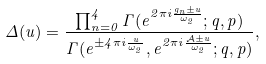<formula> <loc_0><loc_0><loc_500><loc_500>\Delta ( u ) = \frac { \prod _ { n = 0 } ^ { 4 } \Gamma ( e ^ { 2 \pi i \frac { g _ { n } \pm u } { \omega _ { 2 } } } ; q , p ) } { \Gamma ( e ^ { \pm 4 \pi i \frac { u } { \omega _ { 2 } } } , e ^ { 2 \pi i \frac { \mathcal { A } \pm u } { \omega _ { 2 } } } ; q , p ) } ,</formula> 